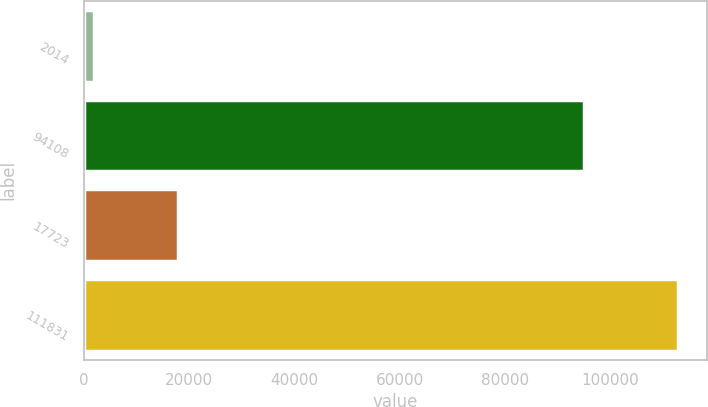Convert chart to OTSL. <chart><loc_0><loc_0><loc_500><loc_500><bar_chart><fcel>2014<fcel>94108<fcel>17723<fcel>111831<nl><fcel>2014<fcel>94913<fcel>17842<fcel>112755<nl></chart> 